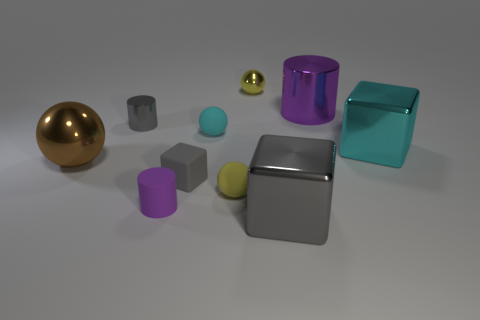Do the cyan matte object and the yellow rubber thing have the same size?
Keep it short and to the point. Yes. Are there any other spheres of the same size as the cyan rubber ball?
Your answer should be very brief. Yes. There is a tiny ball that is on the left side of the small yellow rubber object; what material is it?
Provide a succinct answer. Rubber. What color is the small sphere that is made of the same material as the brown object?
Make the answer very short. Yellow. What number of metal things are brown things or large gray blocks?
Provide a succinct answer. 2. There is a gray shiny object that is the same size as the cyan matte sphere; what shape is it?
Your answer should be very brief. Cylinder. What number of objects are either rubber objects on the right side of the small cyan matte ball or gray cubes that are on the left side of the small yellow matte sphere?
Offer a very short reply. 2. There is a gray cylinder that is the same size as the purple matte cylinder; what is it made of?
Offer a terse response. Metal. What number of other objects are the same material as the tiny cyan thing?
Your response must be concise. 3. Is the number of small gray rubber objects that are behind the tiny cyan sphere the same as the number of large purple metallic cylinders on the right side of the gray metallic cylinder?
Keep it short and to the point. No. 